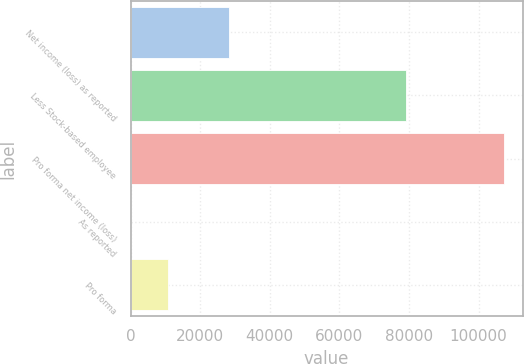Convert chart to OTSL. <chart><loc_0><loc_0><loc_500><loc_500><bar_chart><fcel>Net income (loss) as reported<fcel>Less Stock-based employee<fcel>Pro forma net income (loss)<fcel>As reported<fcel>Pro forma<nl><fcel>28151<fcel>79141<fcel>107292<fcel>0.1<fcel>10729.3<nl></chart> 